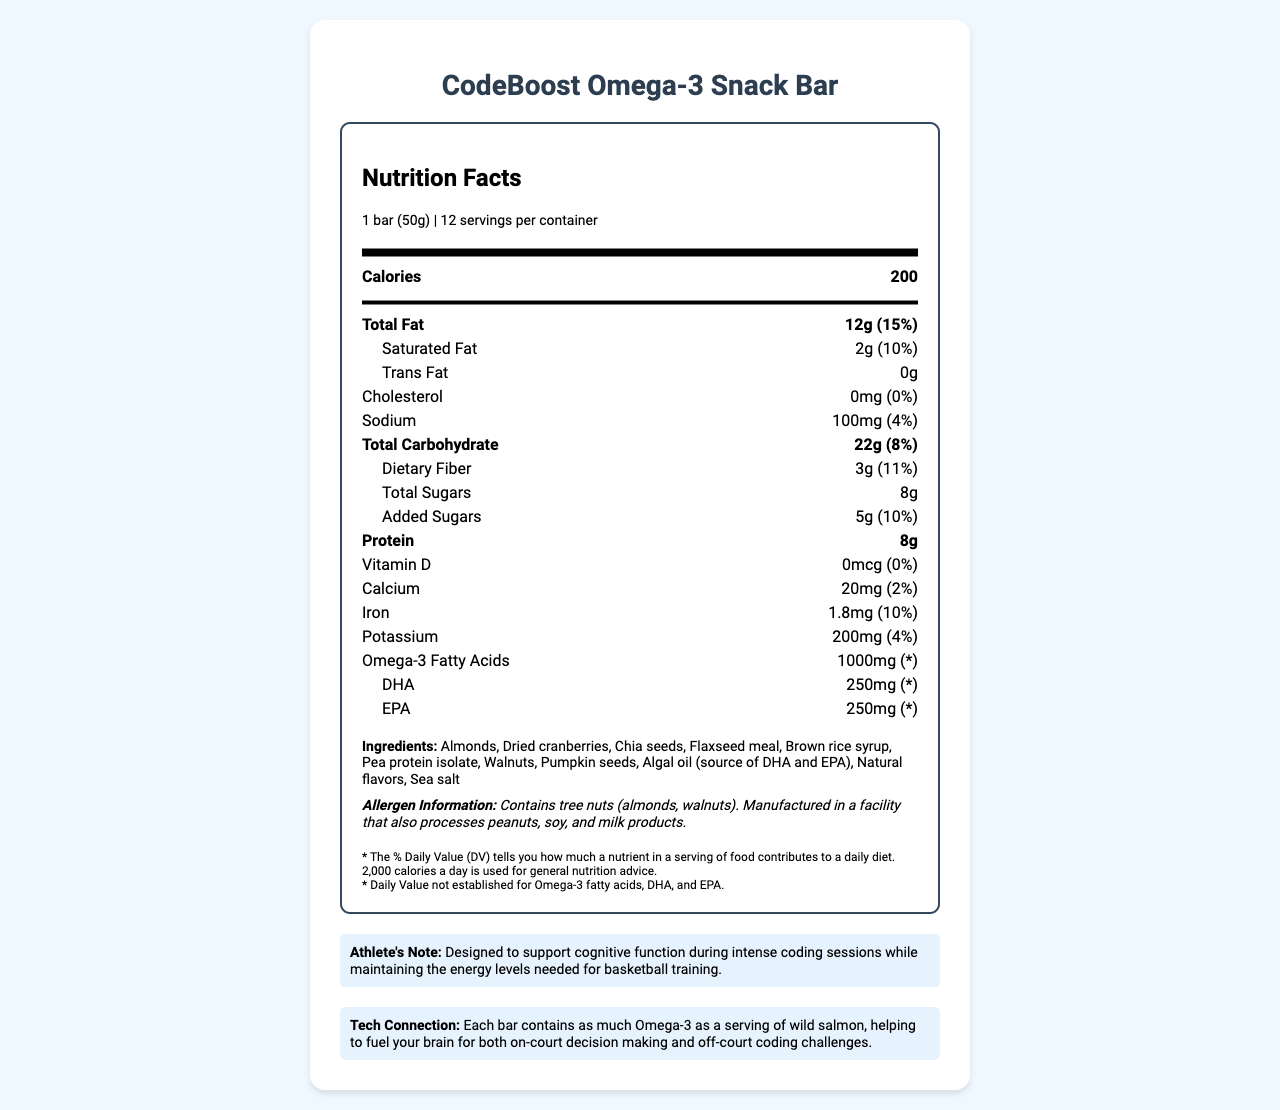what is the total fat per serving? The nutrition label states that the total fat per serving is 12g.
Answer: 12g how much protein does one bar contain? The nutrition facts indicate that one serving (1 bar) contains 8g of protein.
Answer: 8g what are the two main omega-3 fatty acids present in the bar? The ingredients list includes algal oil as a source of DHA and EPA, and these are broken down in the nutrition facts as 250mg each of DHA and EPA.
Answer: DHA and EPA does the snack bar contain any cholesterol? The nutrition label explicitly states that the cholesterol content is 0mg, which means it contains no cholesterol.
Answer: No how many calories are there per serving? The nutrition facts state that each serving (one bar) contains 200 calories.
Answer: 200 how much dietary fiber is provided by one bar? The nutrition facts indicate that each serving (one bar) has 3g of dietary fiber.
Answer: 3g which of the following nutrients is not present in significant amounts in the bar? A. Calcium B. Iron C. Vitamin D The nutrition facts state that Vitamin D is 0mcg (0% DV), whereas Calcium and Iron are present in small amounts.
Answer: C. Vitamin D what is the daily value percentage of saturated fat per serving? A. 5% B. 10% C. 15% The label states that the daily value percentage for saturated fat per serving is 10%.
Answer: B. 10% does the snack bar's ingredient list include any artificial flavors? The ingredient list mentions "Natural flavors," indicating there are no artificial flavors.
Answer: No is the bar suitable for someone with peanut allergies? The allergen information states that the product is manufactured in a facility that also processes peanuts.
Answer: No describe the main idea of the document. The document details the serving size, nutrient amounts, ingredients, allergen information, and additional notes on how the bar supports cognitive function and athletic performance.
Answer: The document provides the nutritional information and benefits of the CodeBoost Omega-3 Snack Bar, highlighting its cognitive function support for coding and energy maintenance for basketball players. what is the source of DHA and EPA in the bar? The ingredient list includes algal oil as the source of DHA and EPA.
Answer: Algal oil how much iron is in one bar? The nutrition label states that one serving contains 1.8mg of iron, which is 10% of the daily value.
Answer: 1.8mg can the daily value for omega-3 fatty acids be determined from the label? The additional information section specifies that the daily value for omega-3 fatty acids, DHA, and EPA has not been established.
Answer: No how much sodium is in one serving? The nutrition facts indicate that one serving contains 100mg of sodium, which is 4% of the daily value.
Answer: 100mg what is the intended benefit of consuming the bar for athletes? The athlete's note mentions that the bar is designed to support cognitive function during intense coding sessions while also maintaining the energy levels required for basketball training.
Answer: To support cognitive function during coding sessions and maintain energy levels needed for basketball training. 